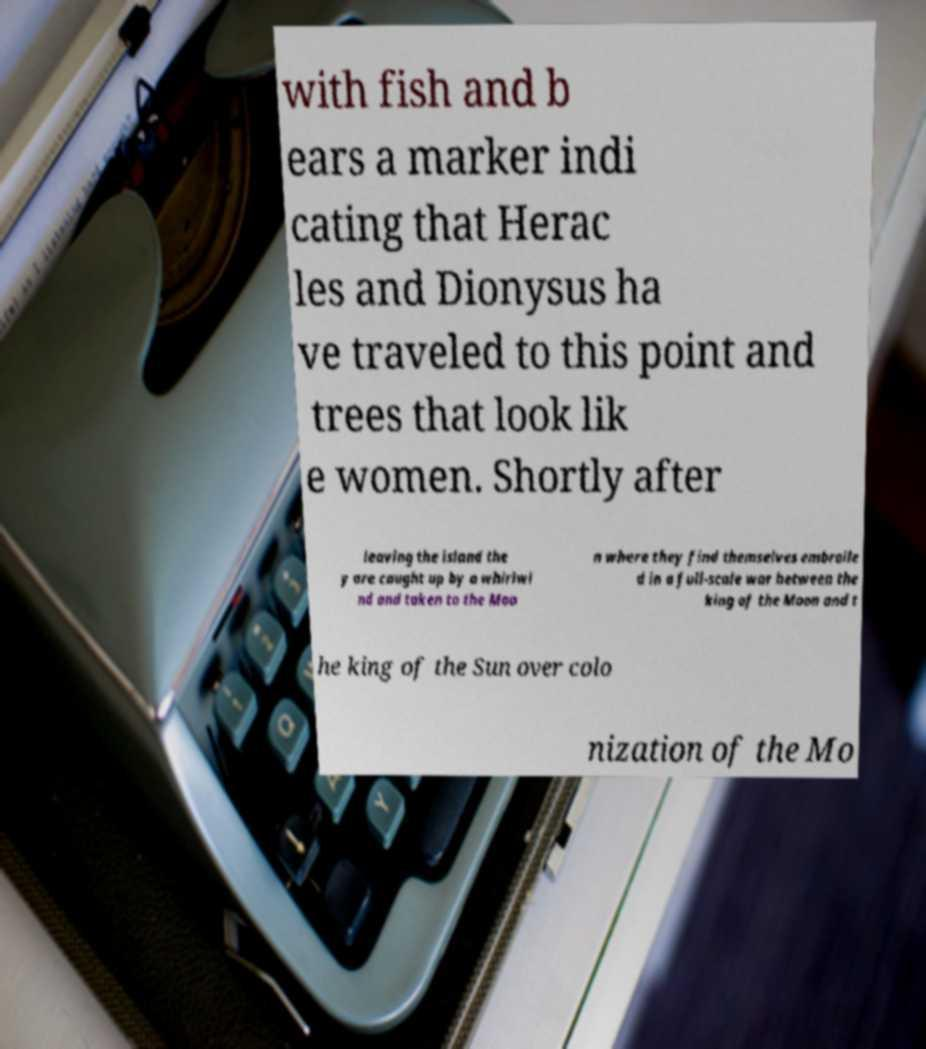Could you extract and type out the text from this image? with fish and b ears a marker indi cating that Herac les and Dionysus ha ve traveled to this point and trees that look lik e women. Shortly after leaving the island the y are caught up by a whirlwi nd and taken to the Moo n where they find themselves embroile d in a full-scale war between the king of the Moon and t he king of the Sun over colo nization of the Mo 